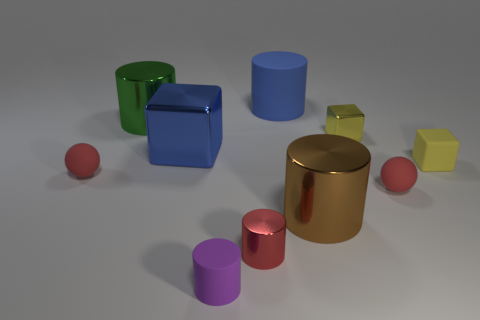How many big metallic cylinders are left of the brown metallic cylinder and right of the big green cylinder? 0 